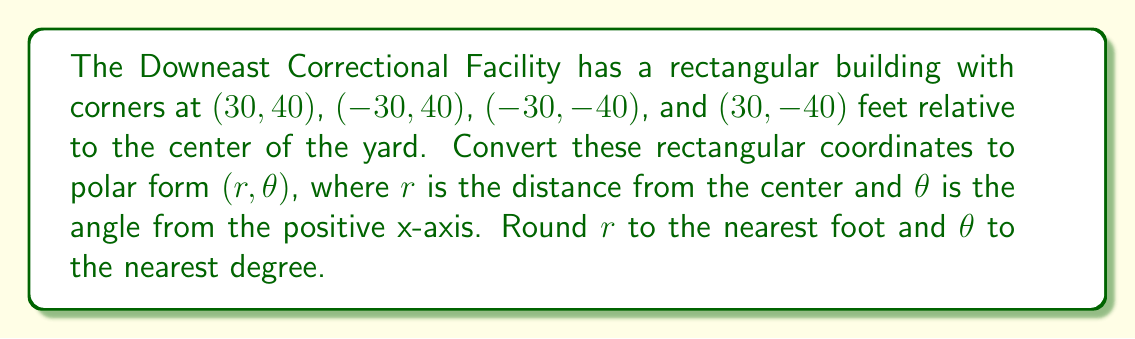What is the answer to this math problem? To convert rectangular coordinates $(x, y)$ to polar coordinates $(r, \theta)$, we use these formulas:

1. $r = \sqrt{x^2 + y^2}$
2. $\theta = \tan^{-1}(\frac{y}{x})$

However, we need to be careful with the arctangent function and adjust the angle based on the quadrant.

Let's convert each corner:

1. Corner (30, 40):
   $r = \sqrt{30^2 + 40^2} = \sqrt{900 + 1600} = \sqrt{2500} = 50$ feet
   $\theta = \tan^{-1}(\frac{40}{30}) \approx 53.13°$

2. Corner (-30, 40):
   $r = \sqrt{(-30)^2 + 40^2} = \sqrt{900 + 1600} = \sqrt{2500} = 50$ feet
   $\theta = 180° - \tan^{-1}(\frac{40}{30}) \approx 180° - 53.13° = 126.87°$

3. Corner (-30, -40):
   $r = \sqrt{(-30)^2 + (-40)^2} = \sqrt{900 + 1600} = \sqrt{2500} = 50$ feet
   $\theta = 180° + \tan^{-1}(\frac{40}{30}) \approx 180° + 53.13° = 233.13°$

4. Corner (30, -40):
   $r = \sqrt{30^2 + (-40)^2} = \sqrt{900 + 1600} = \sqrt{2500} = 50$ feet
   $\theta = 360° - \tan^{-1}(\frac{40}{30}) \approx 360° - 53.13° = 306.87°$

Rounding to the nearest degree for $\theta$:

1. (50, 53°)
2. (50, 127°)
3. (50, 233°)
4. (50, 307°)
Answer: The corners in polar coordinates $(r, \theta)$ are:
1. (50 ft, 53°)
2. (50 ft, 127°)
3. (50 ft, 233°)
4. (50 ft, 307°) 